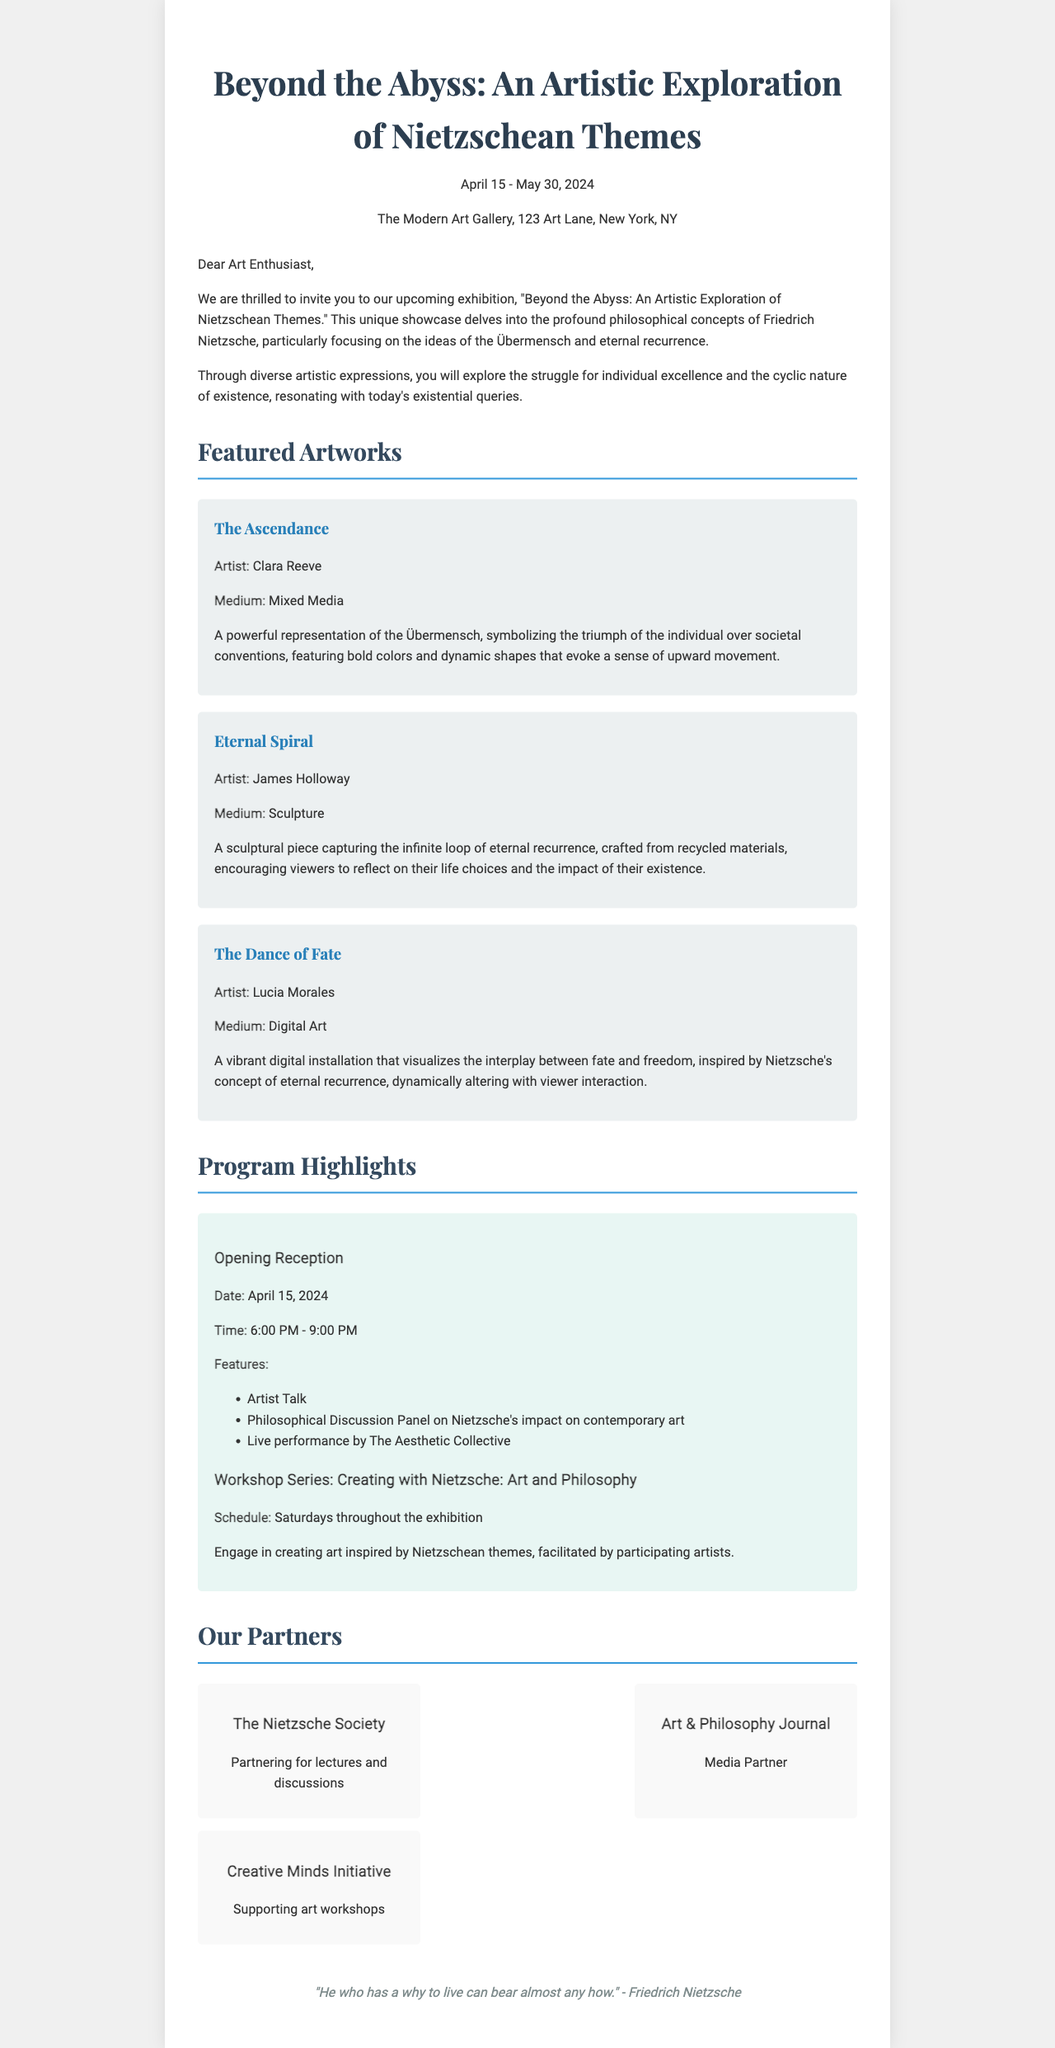What is the title of the exhibition? The title of the exhibition is prominently mentioned at the top of the document.
Answer: Beyond the Abyss: An Artistic Exploration of Nietzschean Themes What are the dates of the exhibition? The exhibition dates are provided in the header section of the document.
Answer: April 15 - May 30, 2024 Where is the exhibition taking place? The location of the exhibition is specified in the introductory section of the document.
Answer: The Modern Art Gallery, 123 Art Lane, New York, NY Who is the artist of "The Ascendance"? The artist's name for this work is presented in the description of the artwork.
Answer: Clara Reeve What is the medium of the artwork "Eternal Spiral"? The medium is stated in the description of the specific artwork.
Answer: Sculpture What event is scheduled for April 15, 2024? The specific event happening on this date is detailed in the program section of the document.
Answer: Opening Reception How often are the workshops held during the exhibition? The schedule provided indicates the frequency of the workshops.
Answer: Saturdays throughout the exhibition Who is the media partner for the exhibition? The information about the media partner is included in the section on partners.
Answer: Art & Philosophy Journal What quote by Nietzsche is included in the footer? The quote is provided at the end of the document and reflects Nietzsche's philosophy.
Answer: "He who has a why to live can bear almost any how." - Friedrich Nietzsche 